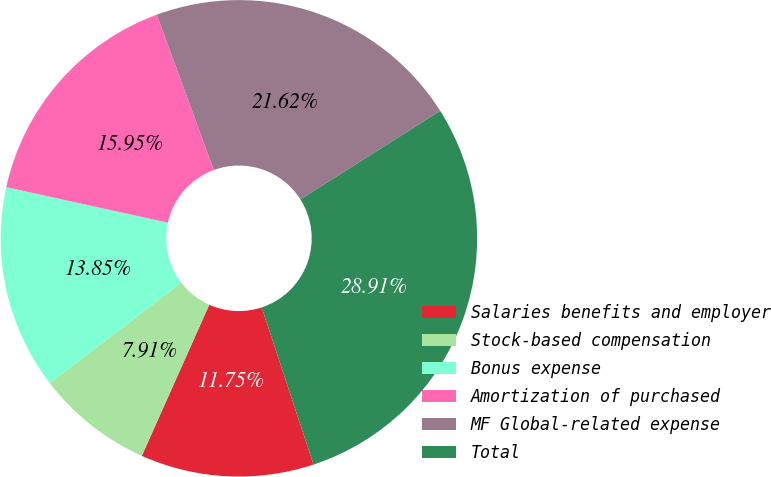Convert chart. <chart><loc_0><loc_0><loc_500><loc_500><pie_chart><fcel>Salaries benefits and employer<fcel>Stock-based compensation<fcel>Bonus expense<fcel>Amortization of purchased<fcel>MF Global-related expense<fcel>Total<nl><fcel>11.75%<fcel>7.91%<fcel>13.85%<fcel>15.95%<fcel>21.62%<fcel>28.91%<nl></chart> 